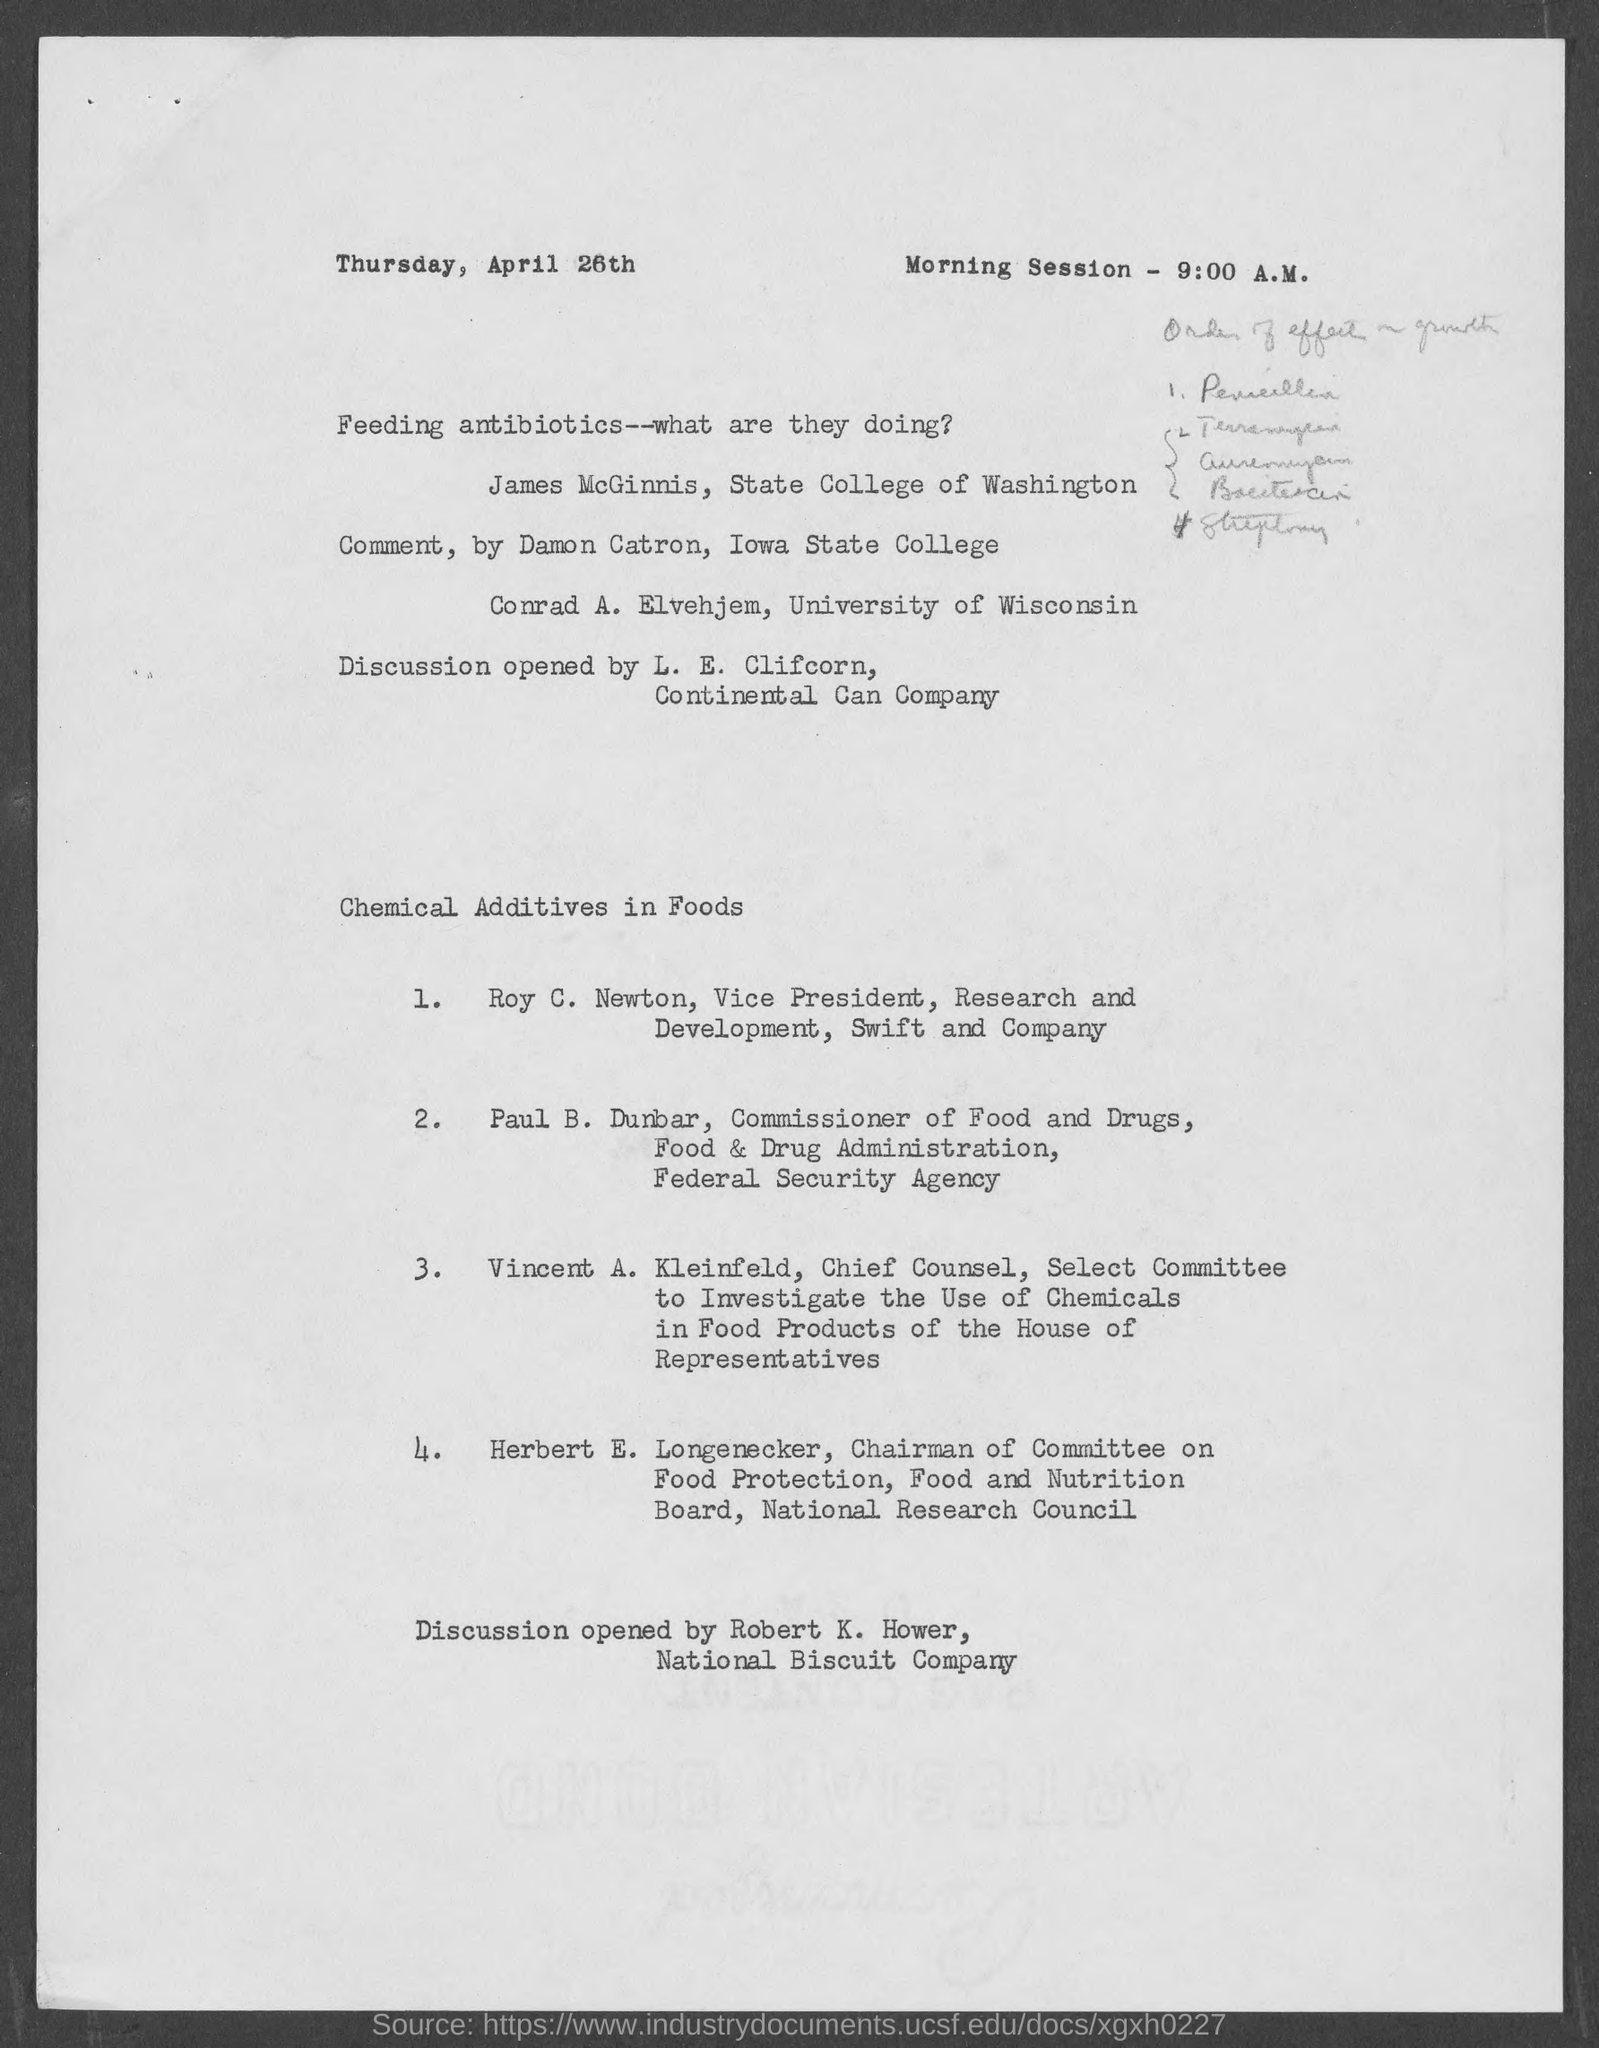Indicate a few pertinent items in this graphic. The document indicates that the date is Thursday, April 26th. The morning session is scheduled for 9:00 A.M. 